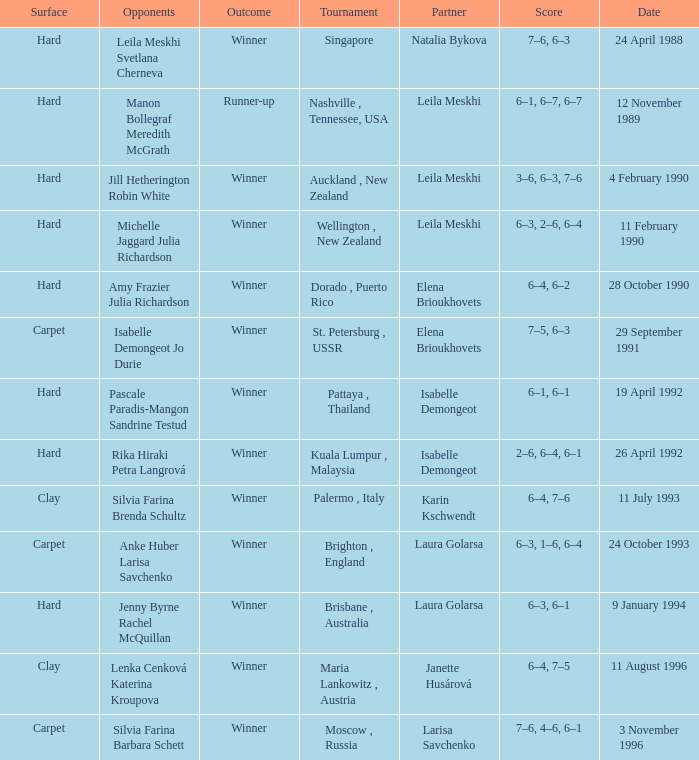On what Date was the Score 6–4, 6–2? 28 October 1990. 